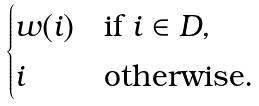<formula> <loc_0><loc_0><loc_500><loc_500>\begin{cases} w ( i ) & \text {if } i \in D , \\ i & \text {otherwise} . \end{cases}</formula> 